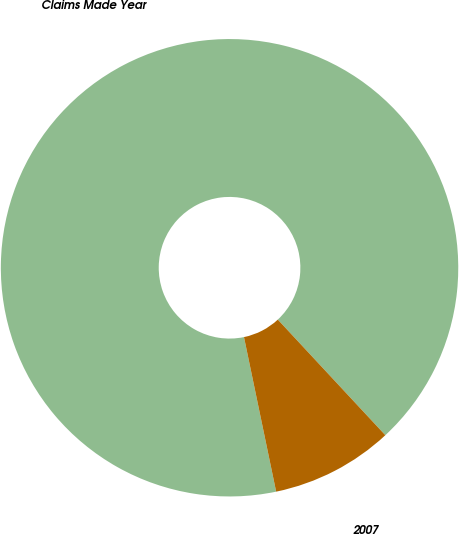Convert chart to OTSL. <chart><loc_0><loc_0><loc_500><loc_500><pie_chart><fcel>Claims Made Year<fcel>2007<nl><fcel>91.34%<fcel>8.66%<nl></chart> 